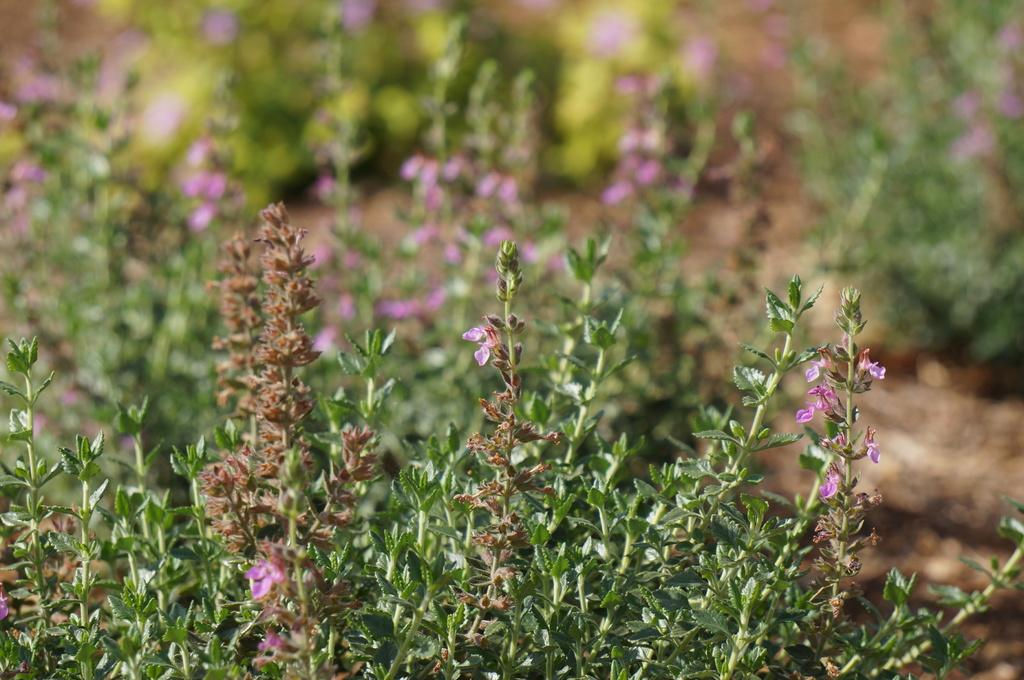What type of living organisms can be seen in the image? Plants can be seen in the image. What additional feature can be observed on the plants? The plants have flowers. What type of jam can be seen on the leaves of the plants in the image? There is no jam present on the leaves of the plants in the image. What type of spark can be seen coming from the flowers in the image? There is no spark present in the image; it features plants with flowers. 